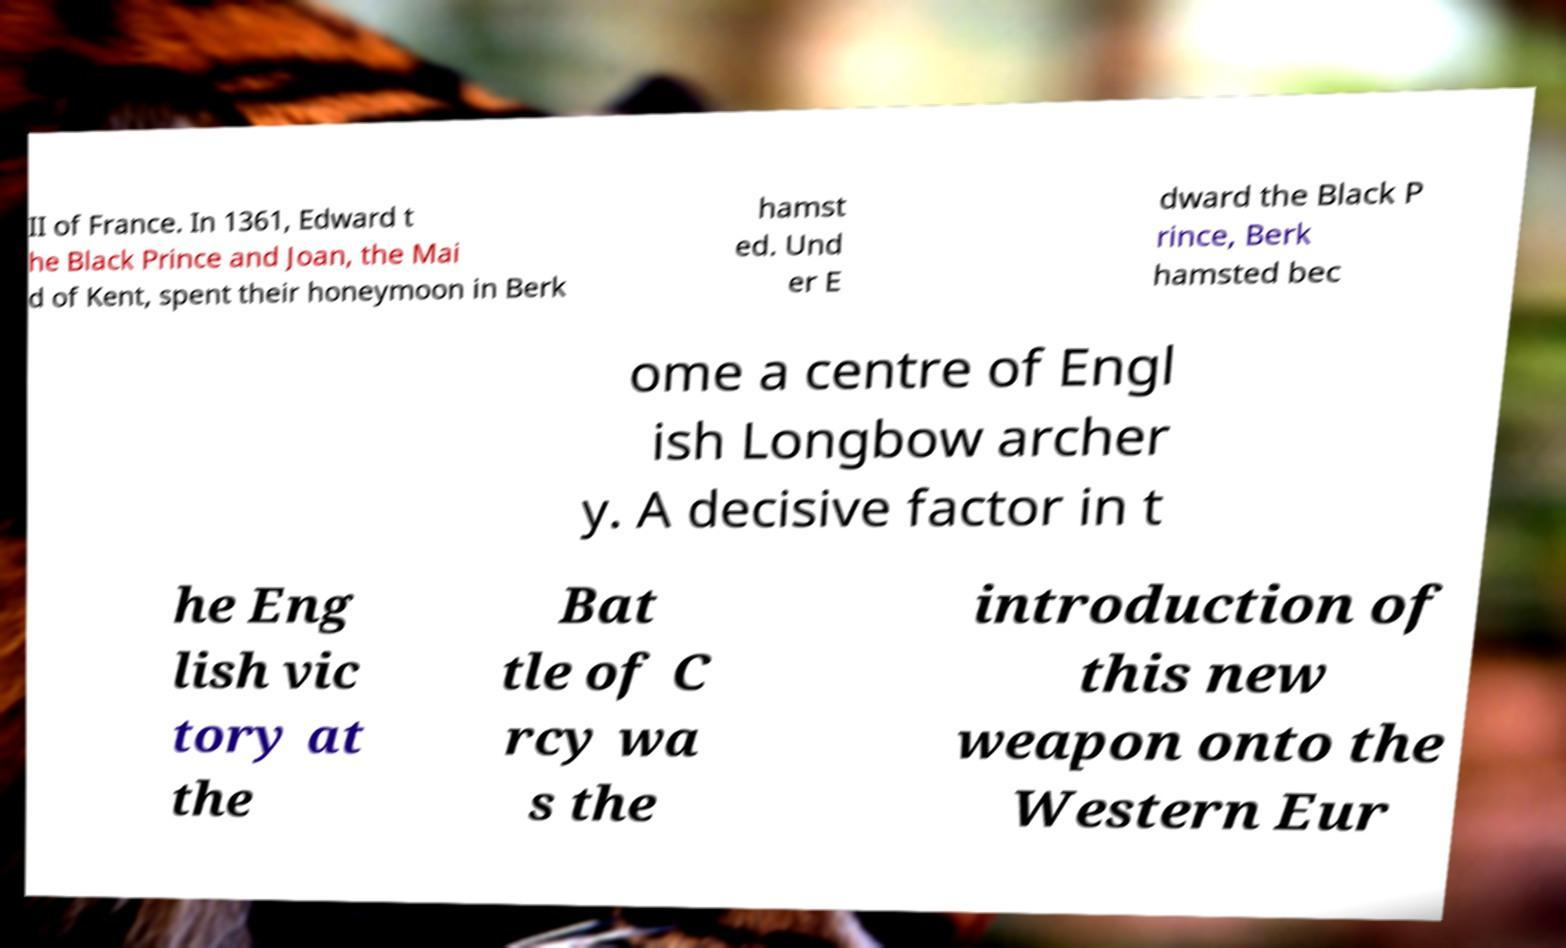Can you read and provide the text displayed in the image?This photo seems to have some interesting text. Can you extract and type it out for me? II of France. In 1361, Edward t he Black Prince and Joan, the Mai d of Kent, spent their honeymoon in Berk hamst ed. Und er E dward the Black P rince, Berk hamsted bec ome a centre of Engl ish Longbow archer y. A decisive factor in t he Eng lish vic tory at the Bat tle of C rcy wa s the introduction of this new weapon onto the Western Eur 